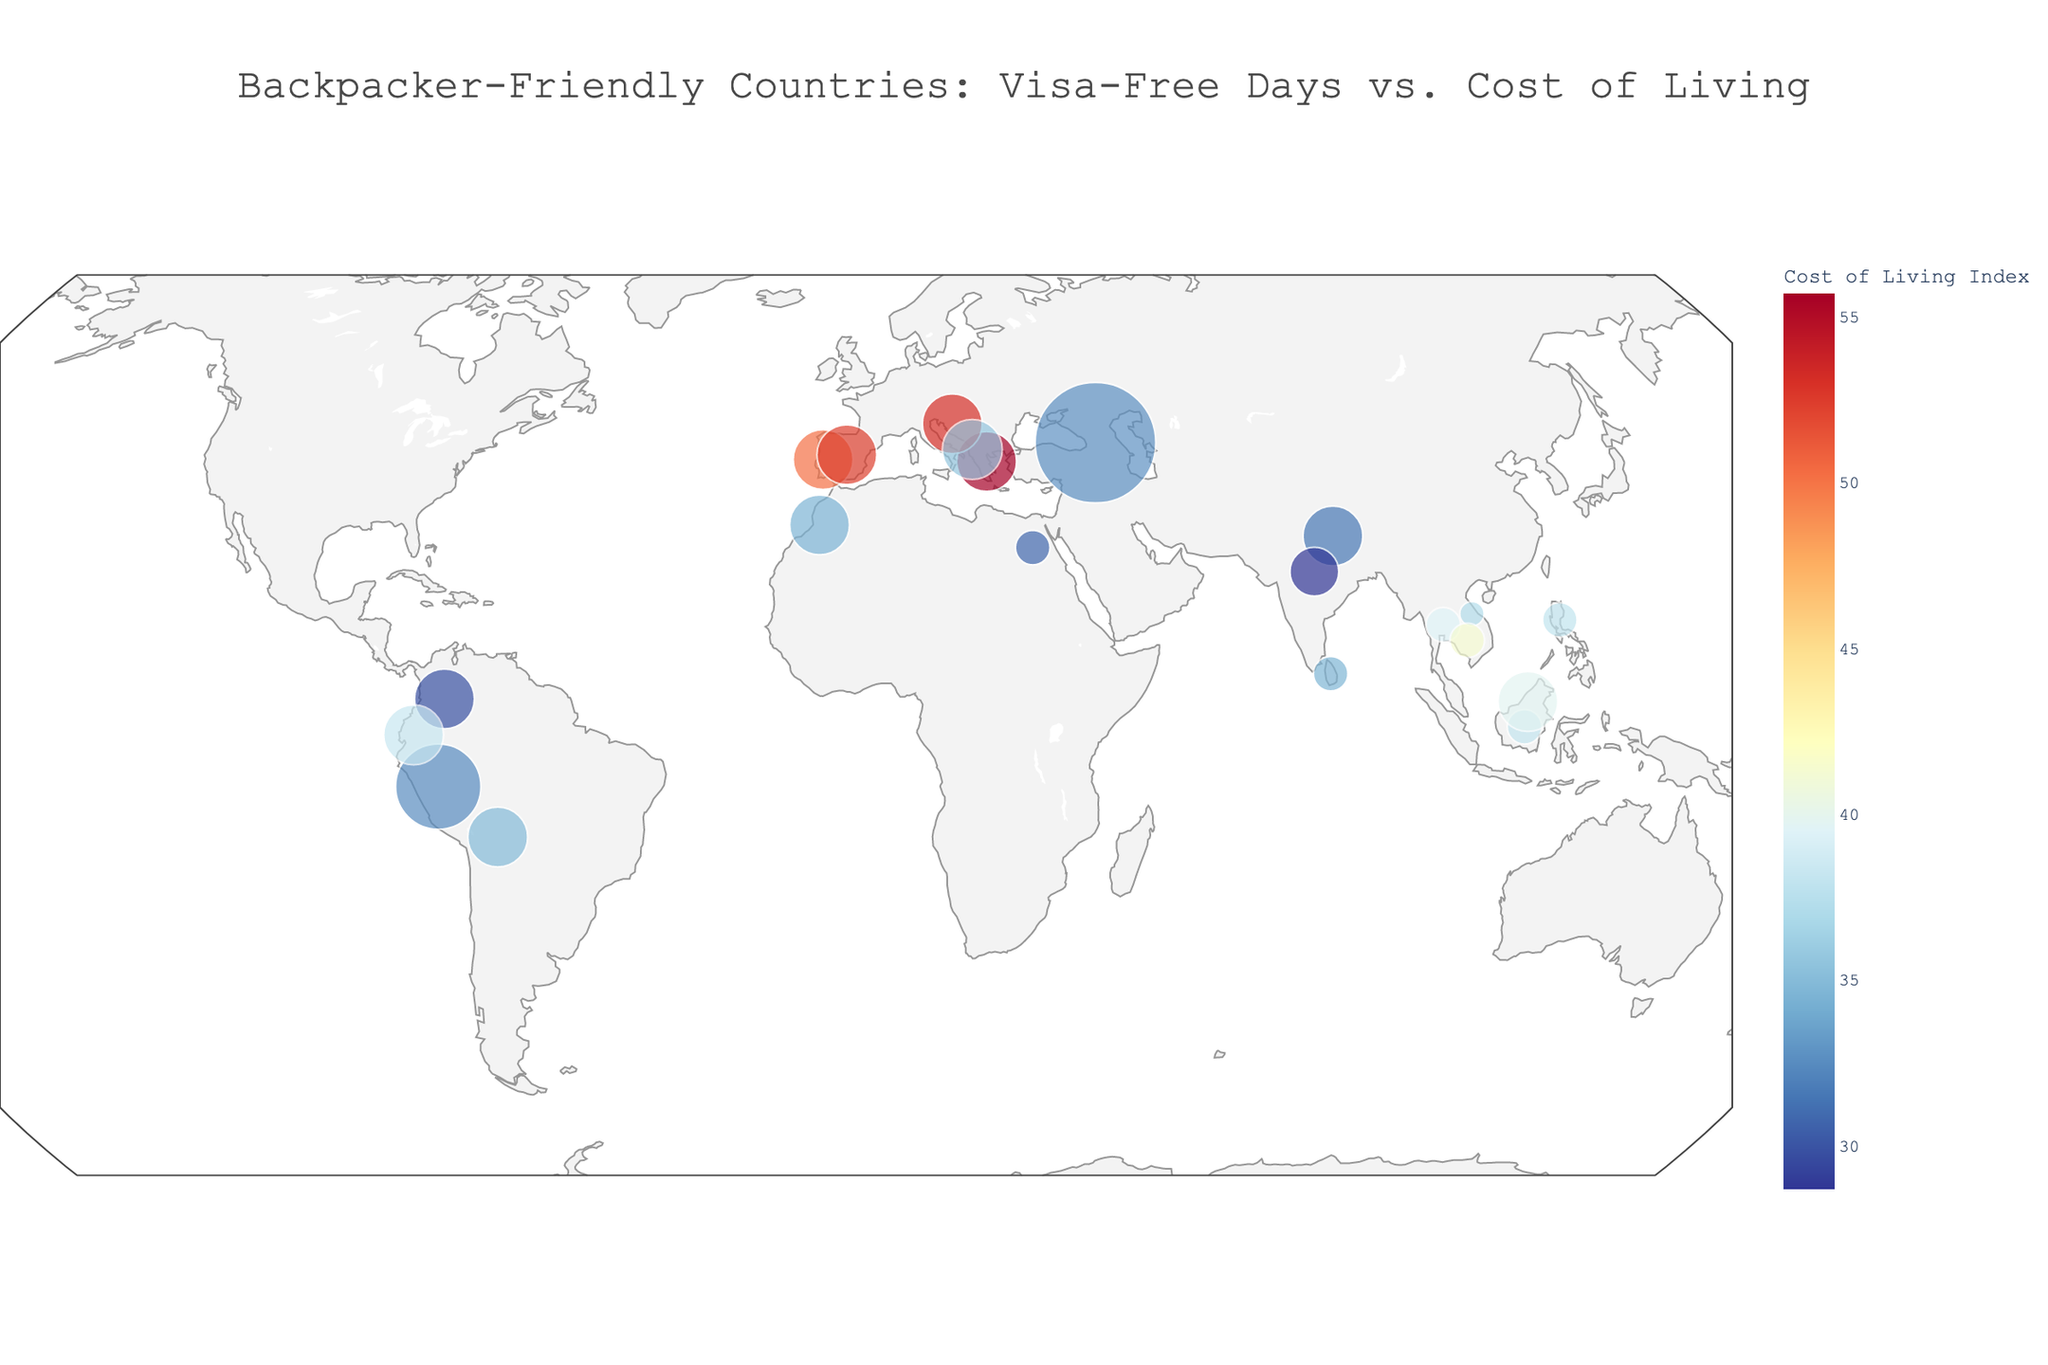What's the country with the highest visa-free days? Look at the size of the data points which represent the visa-free days. The largest point corresponds to Georgia.
Answer: Georgia Which region has the lowest cost of living index? Use the region labels displayed on the figure and compare the cost of living values. South Asia has the lowest cost of living index as indicated by the smaller numbers.
Answer: South Asia Which has a higher cost of living, Malaysia or Thailand? Compare the cost of living index values for Malaysia and Thailand. Malaysia has an index of 39.8 and Thailand has 39.5.
Answer: Malaysia Are there any countries from North America in the figure? By examining the geographic regions and data points on the plot, no countries appear from North America.
Answer: No Which European country offers the longest visa-free stay? Focus on the European region and check their visa-free days. Portugal, Spain, Greece, and Croatia all have 90 days.
Answer: Portugal, Spain, Greece, Croatia List the countries with a cost of living index below 30. Scan the cost of living values of all countries and identify those below 30. Only India and Colombia fit this criterion.
Answer: India, Colombia What is the most backpacker-friendly country in Southeast Asia in terms of cost of living? Within Southeast Asia, compare the cost of living indices. Vietnam has the lowest cost of living index (37.2).
Answer: Vietnam 